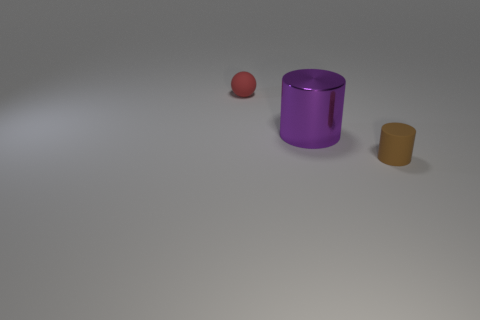What material are these objects likely rendered in, from a 3D artist's perspective? The objects in the image appear to be digitally rendered with a smooth, matte surface texture. The lighting and shadows suggest that the materials could be rough plastics or non-reflective metals. The colors are consistent and solid, indicative of a possible diffuse shader without any specular highlights. How would the perception of these objects change if the lighting were different? If the lighting were to change, it would alter how we perceive the colors and textures of these objects. For instance, with softer ambient light, the objects might look less defined and more integrated with their environment. Alternatively, strong directional light could create deep shadows and enhance the three-dimensionality of the shapes. 